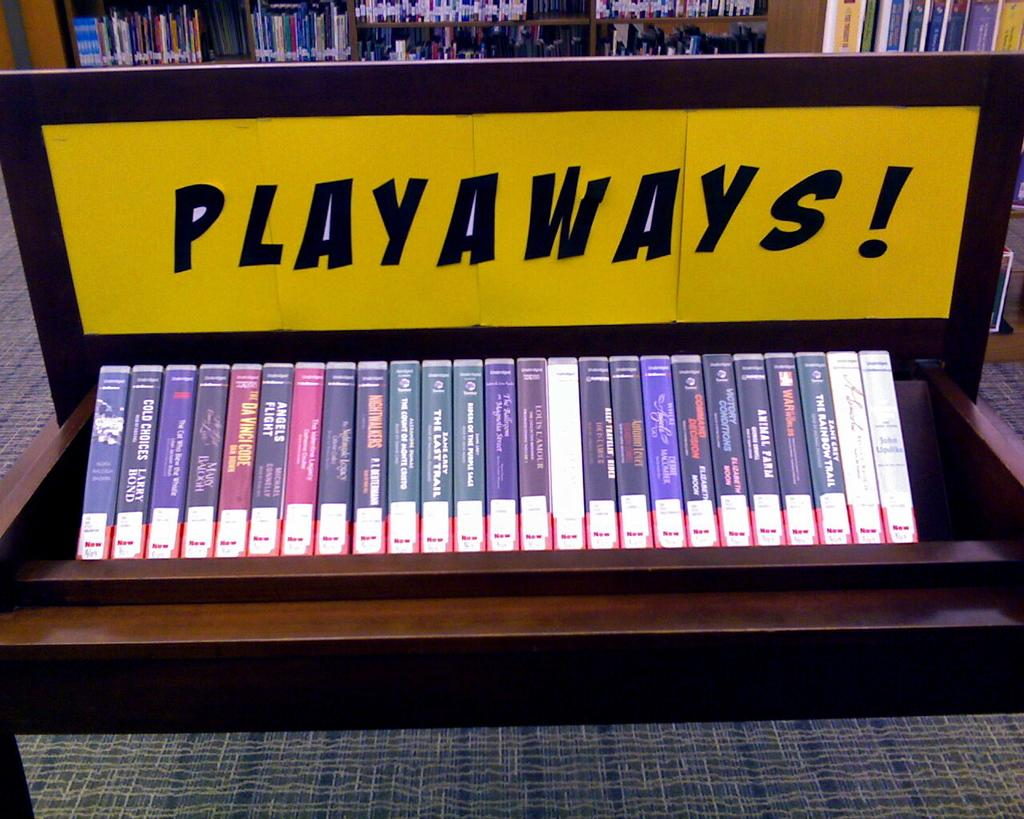<image>
Provide a brief description of the given image. A selection of audiobooks under a sign that says Playaways! 